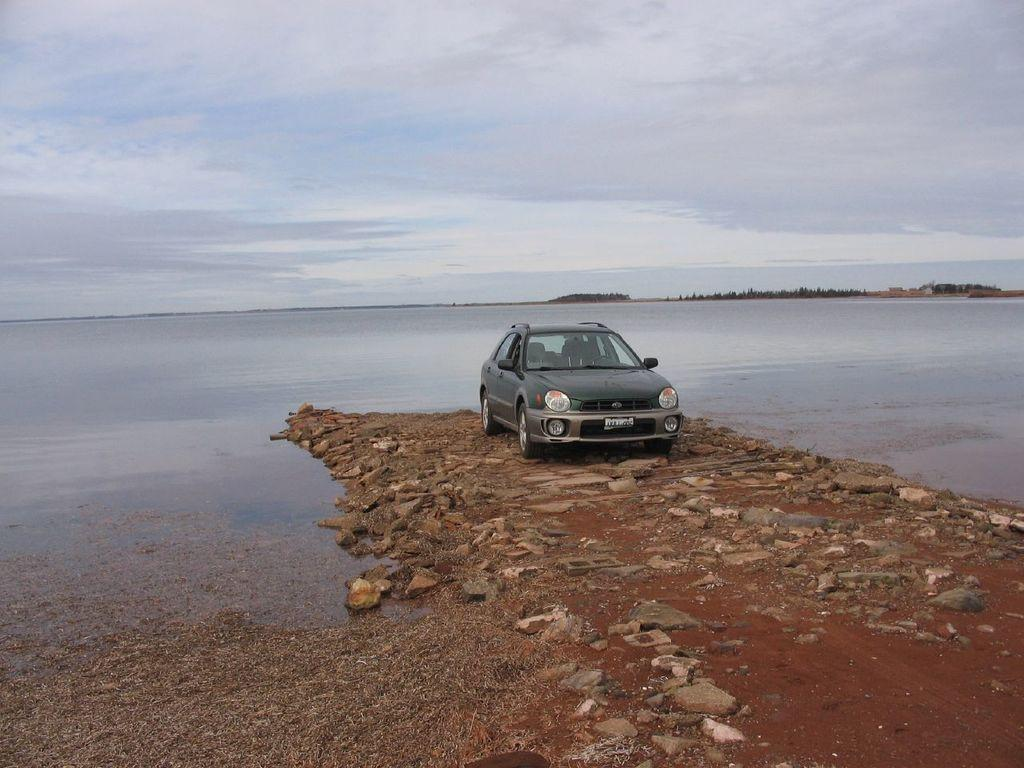What is the main subject of the image? The main subject of the image is a car. What can be seen in the center of the image? There is water in the center of the image. What type of vegetation is visible at the back of the image? There are trees at the back of the image. What is visible at the top of the image? The sky is visible at the top of the image. What song is being played by the car in the image? There is no indication in the image that the car is playing a song, so it cannot be determined from the picture. 